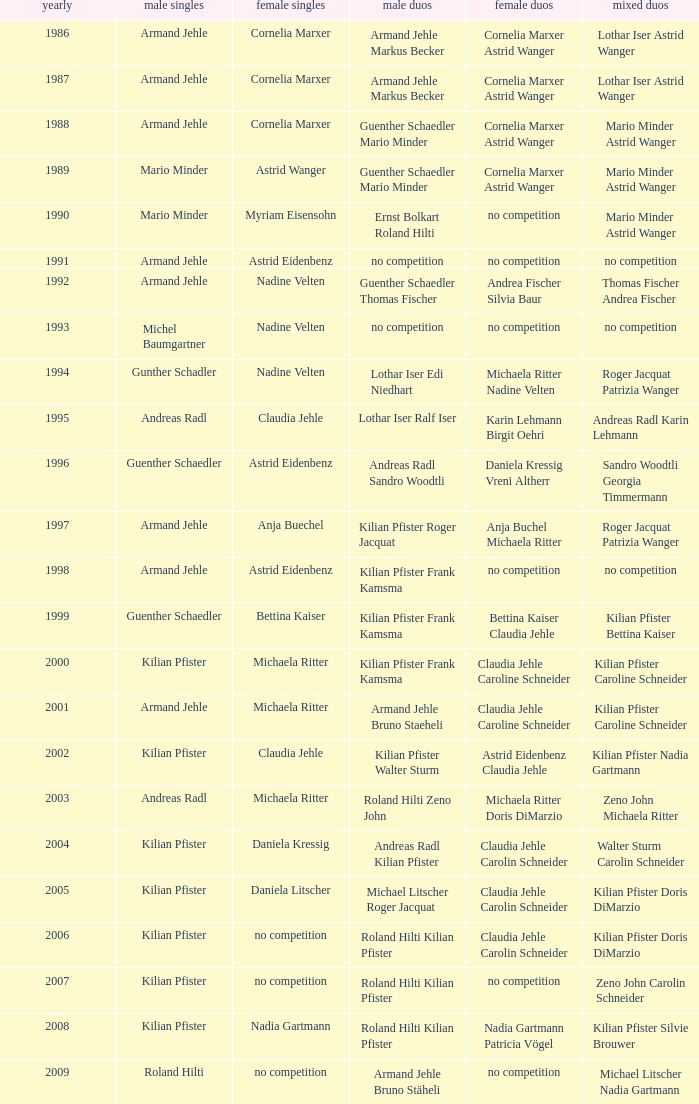In 1987 who was the mens singles Armand Jehle. 